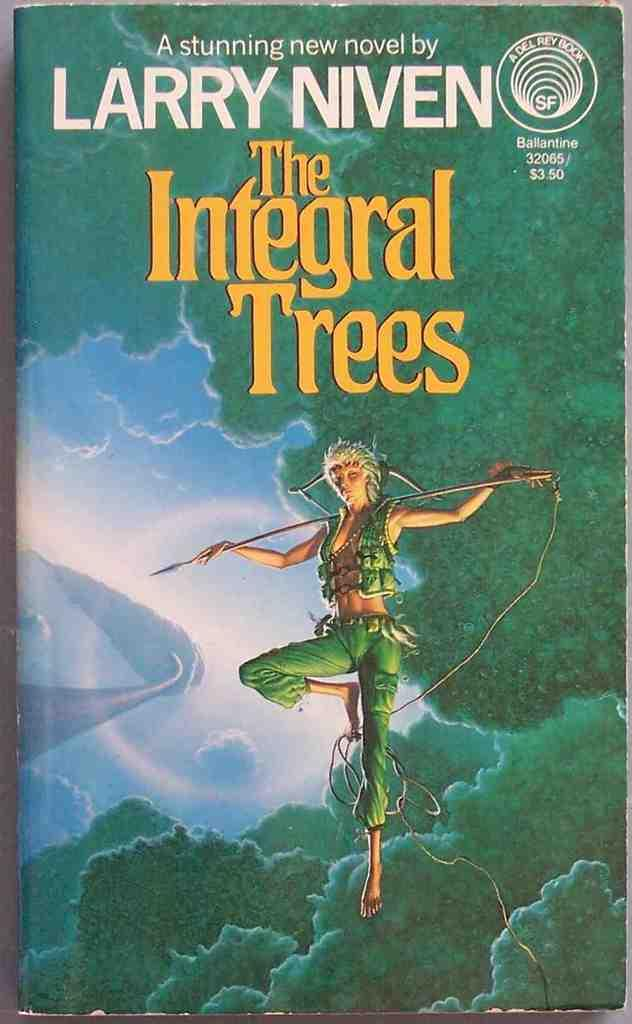Provide a one-sentence caption for the provided image. Larry Niven wrote a novel called The Integral Trees. 